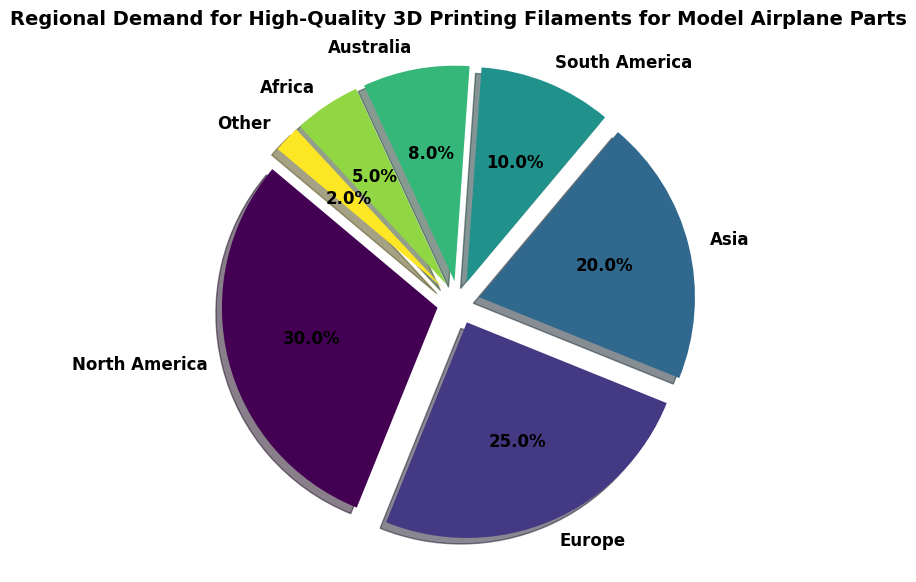Which region has the highest demand for high-quality 3D printing filaments for model airplane parts? The pie chart shows the demand distribution for each region. By observing the slices, the largest one corresponds to North America.
Answer: North America What is the combined demand percentage for Europe and Asia? From the chart, Europe has a demand percentage of 25%, and Asia has 20%. Adding them together: 25% + 20% = 45%
Answer: 45% How does the demand in South America compare to Africa? By comparing the respective slices, South America has a 10% share, while Africa has a 5% share, making South America's demand twice that of Africa.
Answer: South America's demand is twice that of Africa What is the total demand percentage for regions with less than 10% demand each? The regions with less than 10% demand each are South America (10%), Australia (8%), Africa (5%), and Other (2%). Adding their percentages: 10% + 8% + 5% + 2% = 25%
Answer: 25% Which region has a slightly smaller demand than Asia? By looking at the pie chart, Australia has an 8% demand compared to Asia’s 20%. Therefore, the closest smaller demand region is Australia but with a significant difference.
Answer: Australia, with a significant difference How much larger is the demand percentage for North America compared to Europe? North America has a demand percentage of 30%, and Europe has 25%. The difference is calculated by subtracting: 30% - 25% = 5%
Answer: 5% What proportion of the total demand is occupied by the three regions with the highest demands? The three regions with the highest demands are North America (30%), Europe (25%), and Asia (20%). Adding these together: 30% + 25% + 20% = 75%
Answer: 75% Which region has the smallest demand share for high-quality 3D printing filaments for model airplane parts? "Other" has the smallest demand as represented by the smallest slice at 2% in the pie chart.
Answer: Other (2%) What is the difference in demand between the top two regions with the highest and lowest demands? The highest demand is North America (30%), and the lowest is Other (2%). Subtracting these values gives 30% - 2% = 28%
Answer: 28% 